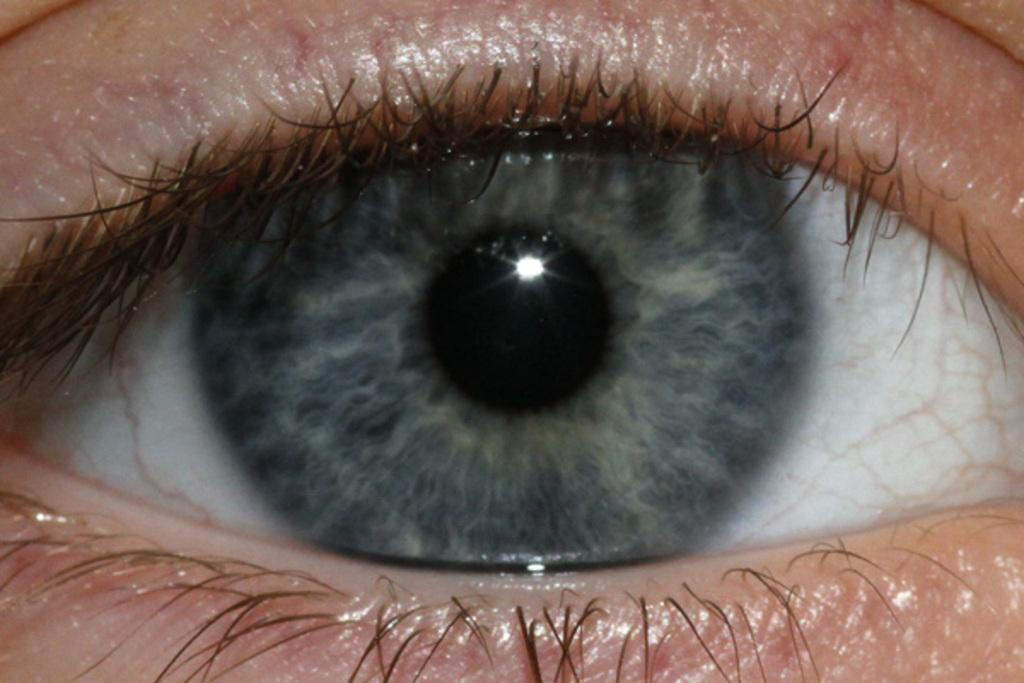What is the main subject of the picture? The main subject of the picture is a human eye. What can be seen within the eye? The iris and pupil are visible in the eye. Are there any features surrounding the eye? Yes, eyelashes are present around the eye. What type of coat is the eye wearing in the image? There is no coat present in the image, as the subject is a human eye. What market is depicted in the background of the image? There is no market present in the image; it solely features a human eye. 